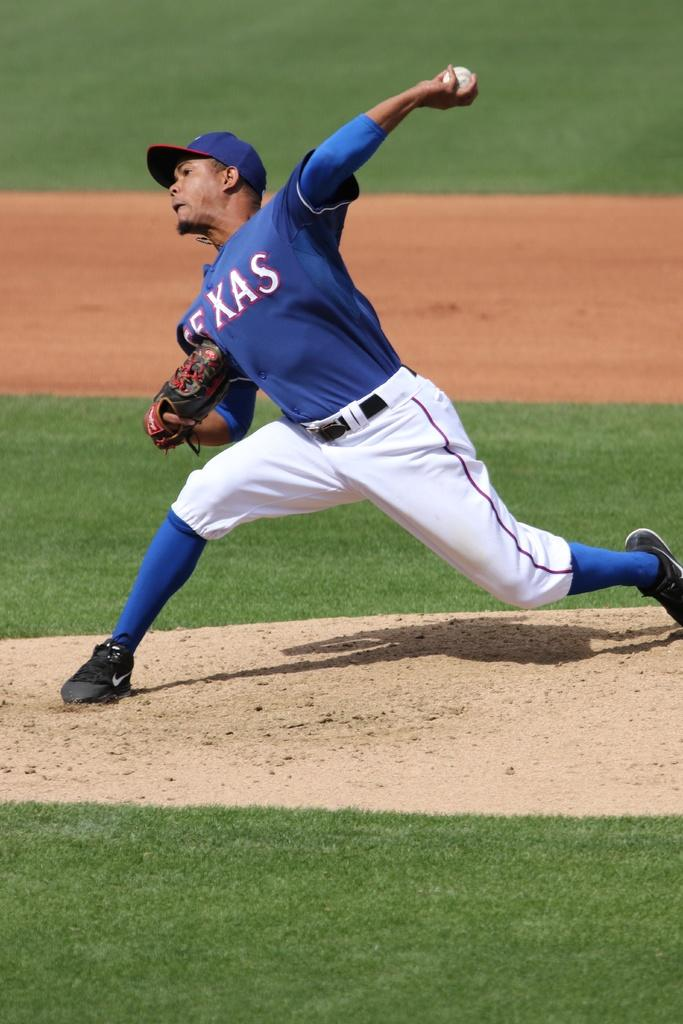Provide a one-sentence caption for the provided image. Texas is the team name shown on the pitcher's jersey. 